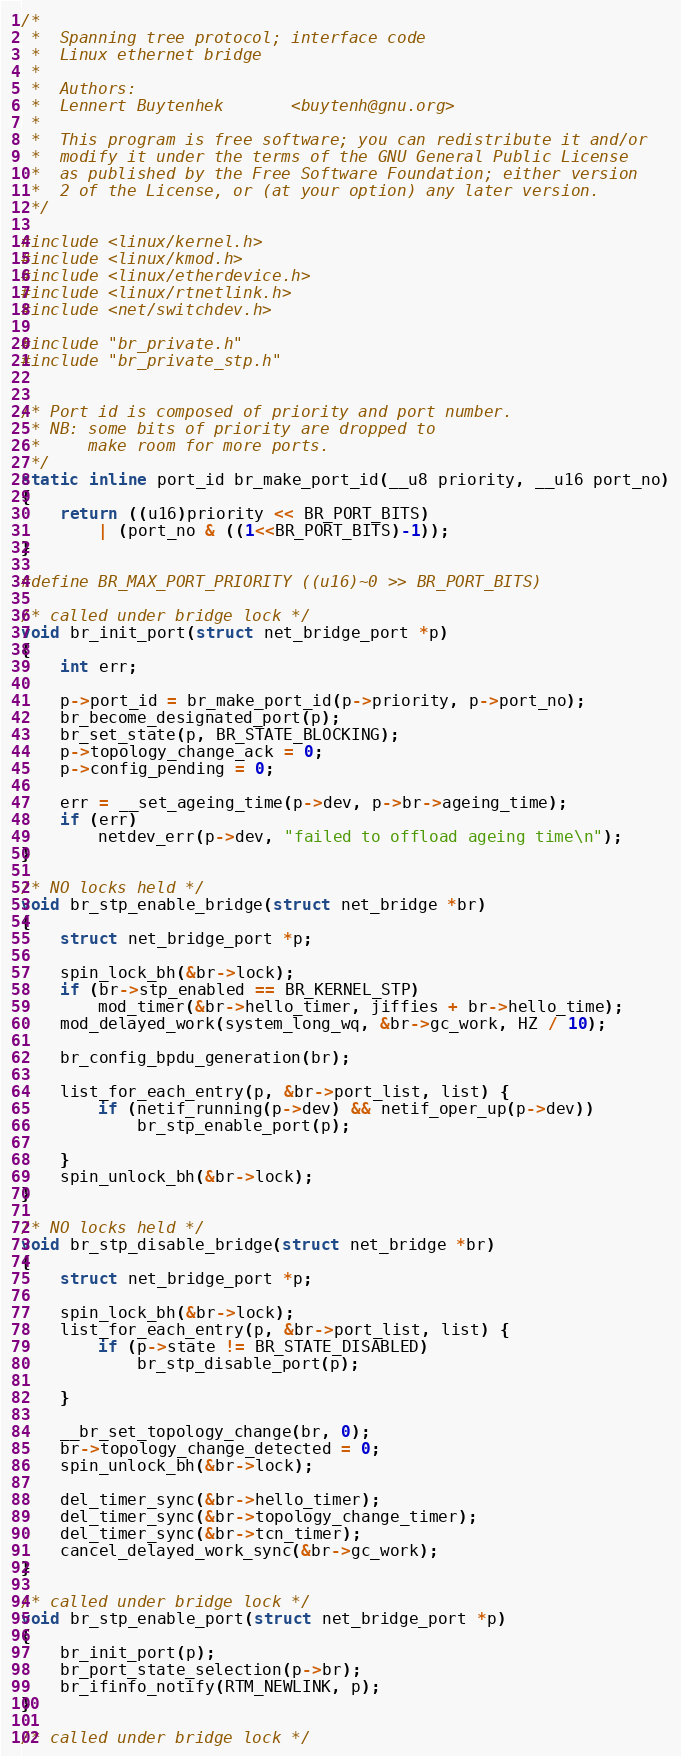Convert code to text. <code><loc_0><loc_0><loc_500><loc_500><_C_>/*
 *	Spanning tree protocol; interface code
 *	Linux ethernet bridge
 *
 *	Authors:
 *	Lennert Buytenhek		<buytenh@gnu.org>
 *
 *	This program is free software; you can redistribute it and/or
 *	modify it under the terms of the GNU General Public License
 *	as published by the Free Software Foundation; either version
 *	2 of the License, or (at your option) any later version.
 */

#include <linux/kernel.h>
#include <linux/kmod.h>
#include <linux/etherdevice.h>
#include <linux/rtnetlink.h>
#include <net/switchdev.h>

#include "br_private.h"
#include "br_private_stp.h"


/* Port id is composed of priority and port number.
 * NB: some bits of priority are dropped to
 *     make room for more ports.
 */
static inline port_id br_make_port_id(__u8 priority, __u16 port_no)
{
	return ((u16)priority << BR_PORT_BITS)
		| (port_no & ((1<<BR_PORT_BITS)-1));
}

#define BR_MAX_PORT_PRIORITY ((u16)~0 >> BR_PORT_BITS)

/* called under bridge lock */
void br_init_port(struct net_bridge_port *p)
{
	int err;

	p->port_id = br_make_port_id(p->priority, p->port_no);
	br_become_designated_port(p);
	br_set_state(p, BR_STATE_BLOCKING);
	p->topology_change_ack = 0;
	p->config_pending = 0;

	err = __set_ageing_time(p->dev, p->br->ageing_time);
	if (err)
		netdev_err(p->dev, "failed to offload ageing time\n");
}

/* NO locks held */
void br_stp_enable_bridge(struct net_bridge *br)
{
	struct net_bridge_port *p;

	spin_lock_bh(&br->lock);
	if (br->stp_enabled == BR_KERNEL_STP)
		mod_timer(&br->hello_timer, jiffies + br->hello_time);
	mod_delayed_work(system_long_wq, &br->gc_work, HZ / 10);

	br_config_bpdu_generation(br);

	list_for_each_entry(p, &br->port_list, list) {
		if (netif_running(p->dev) && netif_oper_up(p->dev))
			br_stp_enable_port(p);

	}
	spin_unlock_bh(&br->lock);
}

/* NO locks held */
void br_stp_disable_bridge(struct net_bridge *br)
{
	struct net_bridge_port *p;

	spin_lock_bh(&br->lock);
	list_for_each_entry(p, &br->port_list, list) {
		if (p->state != BR_STATE_DISABLED)
			br_stp_disable_port(p);

	}

	__br_set_topology_change(br, 0);
	br->topology_change_detected = 0;
	spin_unlock_bh(&br->lock);

	del_timer_sync(&br->hello_timer);
	del_timer_sync(&br->topology_change_timer);
	del_timer_sync(&br->tcn_timer);
	cancel_delayed_work_sync(&br->gc_work);
}

/* called under bridge lock */
void br_stp_enable_port(struct net_bridge_port *p)
{
	br_init_port(p);
	br_port_state_selection(p->br);
	br_ifinfo_notify(RTM_NEWLINK, p);
}

/* called under bridge lock */</code> 